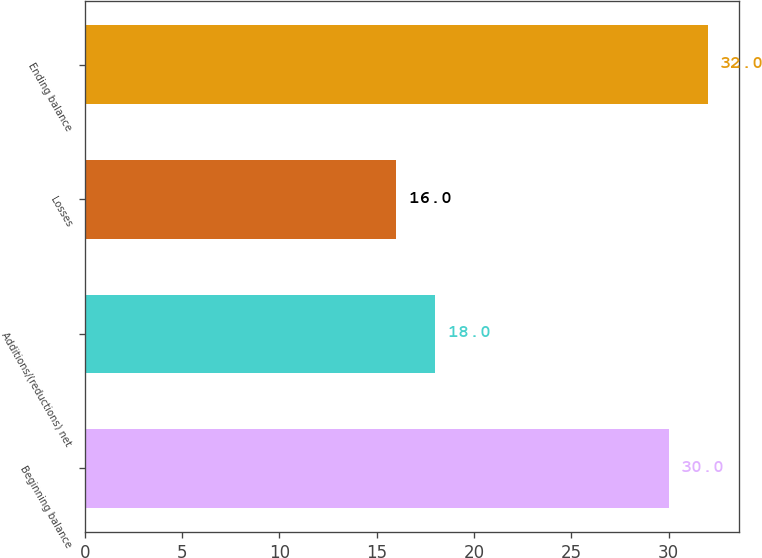Convert chart. <chart><loc_0><loc_0><loc_500><loc_500><bar_chart><fcel>Beginning balance<fcel>Additions/(reductions) net<fcel>Losses<fcel>Ending balance<nl><fcel>30<fcel>18<fcel>16<fcel>32<nl></chart> 